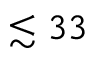<formula> <loc_0><loc_0><loc_500><loc_500>\lesssim 3 3</formula> 